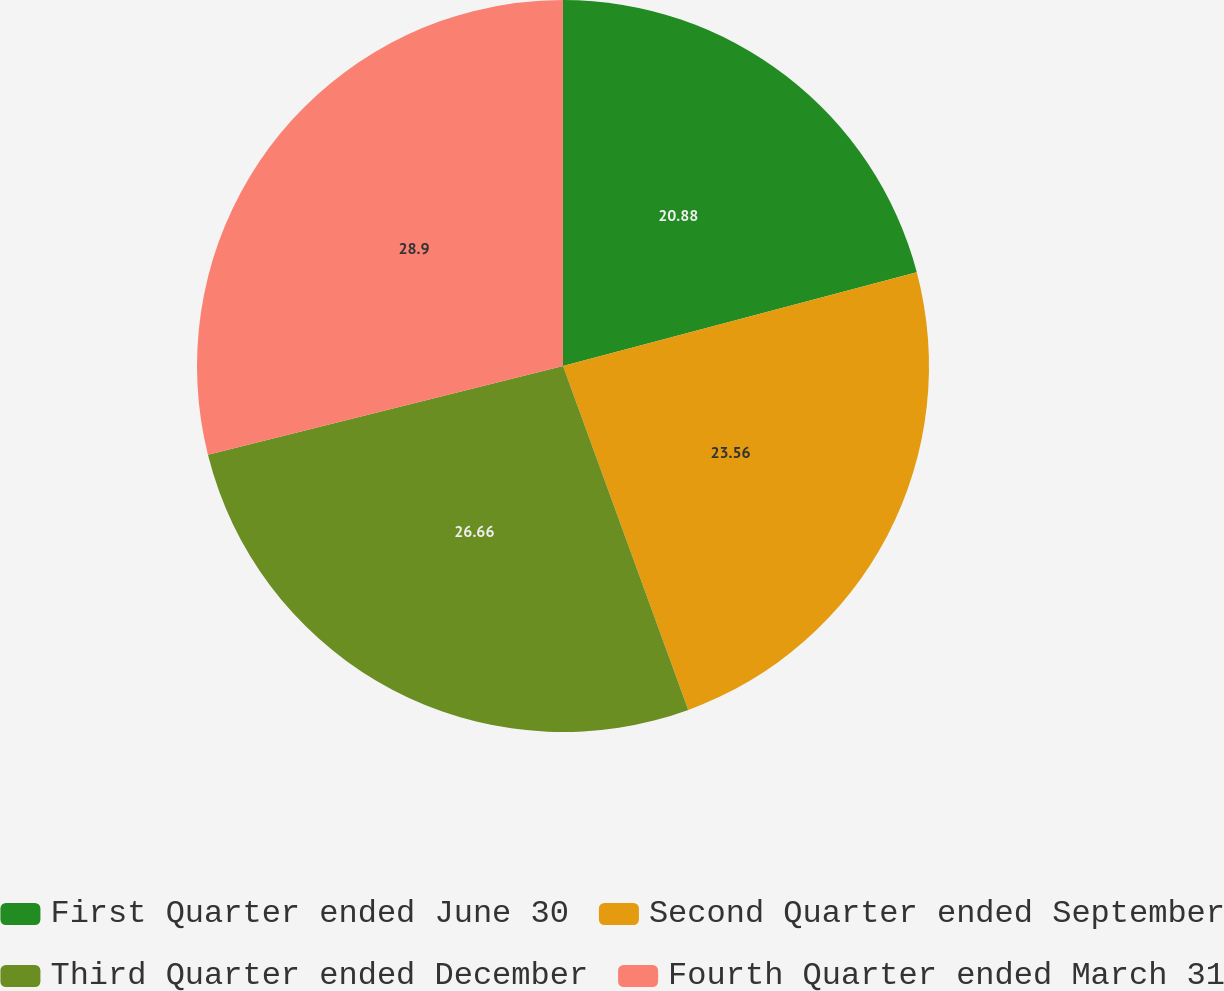Convert chart to OTSL. <chart><loc_0><loc_0><loc_500><loc_500><pie_chart><fcel>First Quarter ended June 30<fcel>Second Quarter ended September<fcel>Third Quarter ended December<fcel>Fourth Quarter ended March 31<nl><fcel>20.88%<fcel>23.56%<fcel>26.66%<fcel>28.9%<nl></chart> 